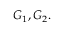<formula> <loc_0><loc_0><loc_500><loc_500>G _ { 1 } , G _ { 2 } .</formula> 